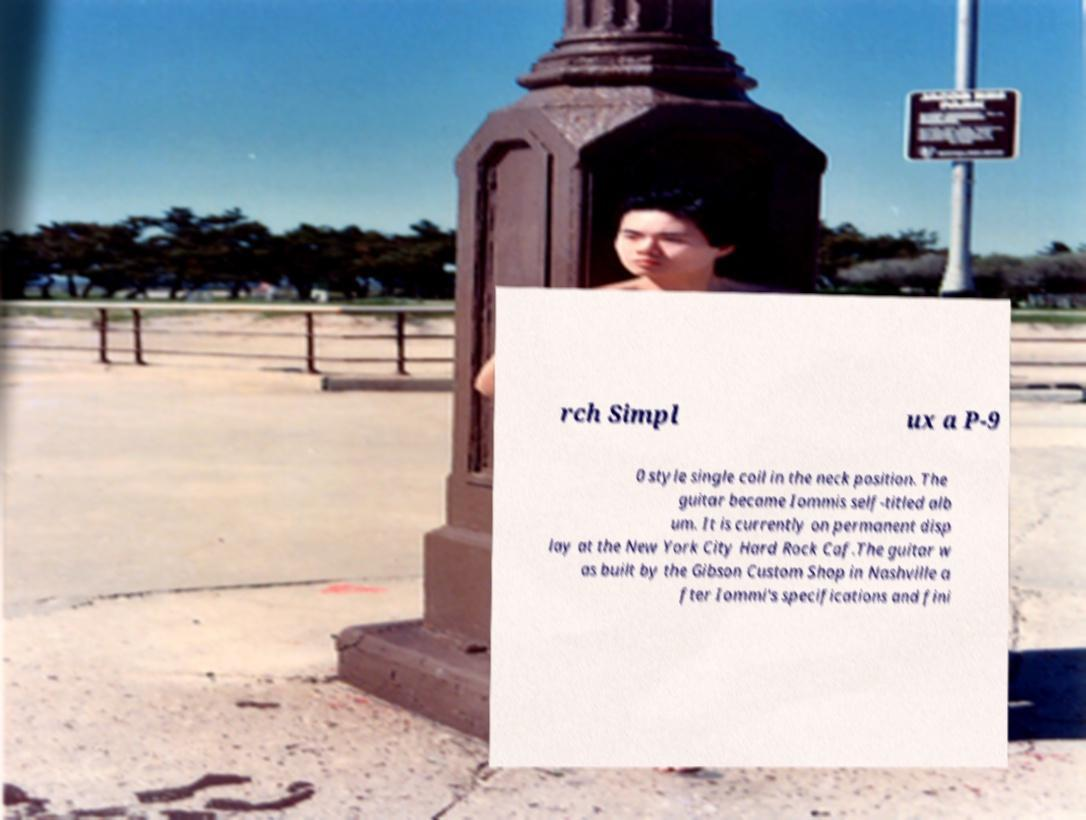Can you accurately transcribe the text from the provided image for me? rch Simpl ux a P-9 0 style single coil in the neck position. The guitar became Iommis self-titled alb um. It is currently on permanent disp lay at the New York City Hard Rock Caf.The guitar w as built by the Gibson Custom Shop in Nashville a fter Iommi's specifications and fini 